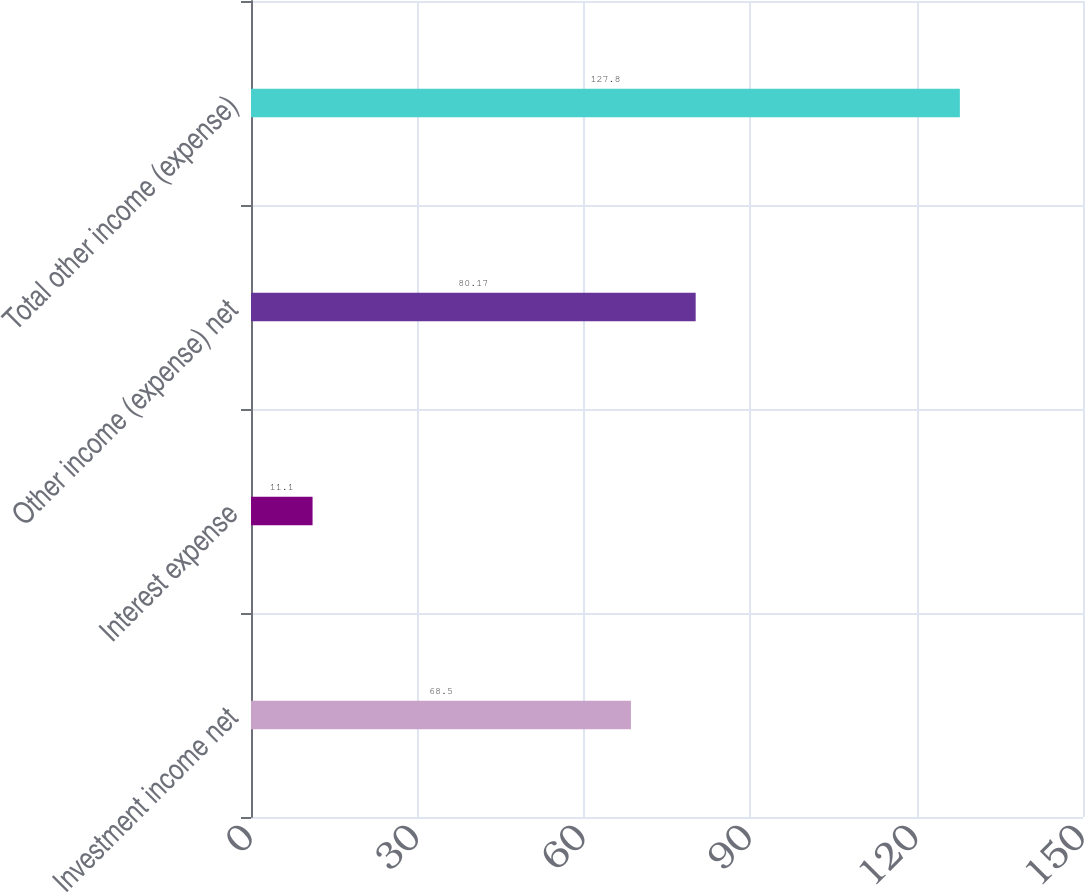Convert chart to OTSL. <chart><loc_0><loc_0><loc_500><loc_500><bar_chart><fcel>Investment income net<fcel>Interest expense<fcel>Other income (expense) net<fcel>Total other income (expense)<nl><fcel>68.5<fcel>11.1<fcel>80.17<fcel>127.8<nl></chart> 